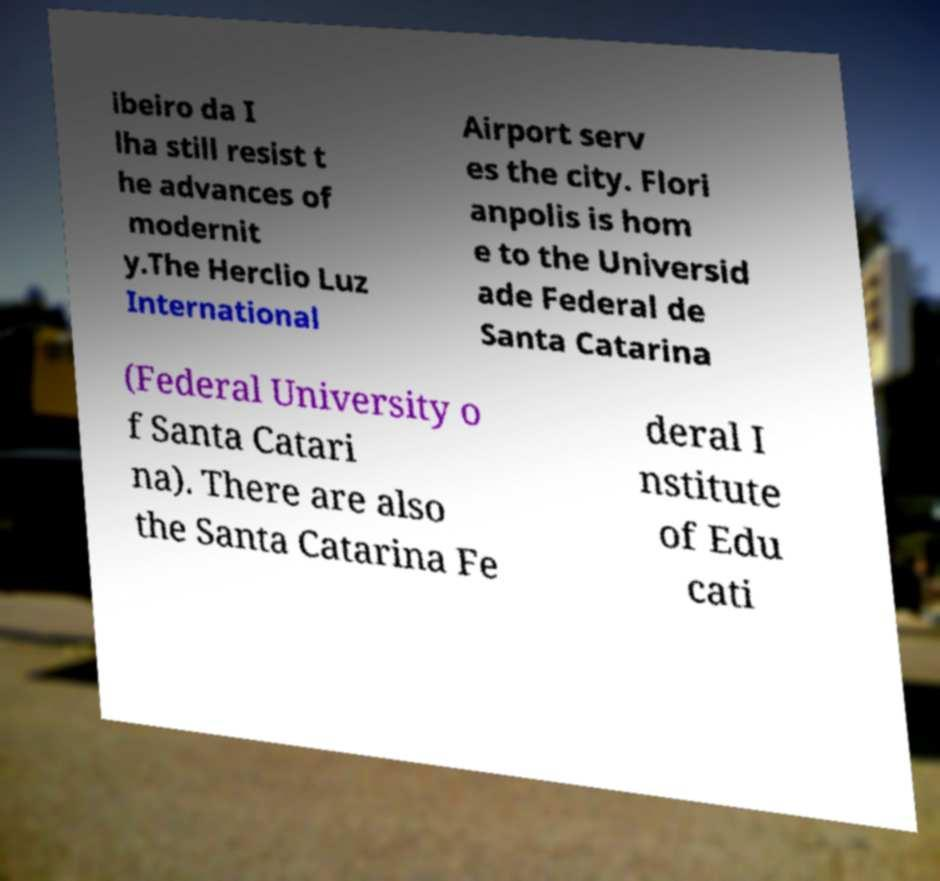Can you accurately transcribe the text from the provided image for me? ibeiro da I lha still resist t he advances of modernit y.The Herclio Luz International Airport serv es the city. Flori anpolis is hom e to the Universid ade Federal de Santa Catarina (Federal University o f Santa Catari na). There are also the Santa Catarina Fe deral I nstitute of Edu cati 